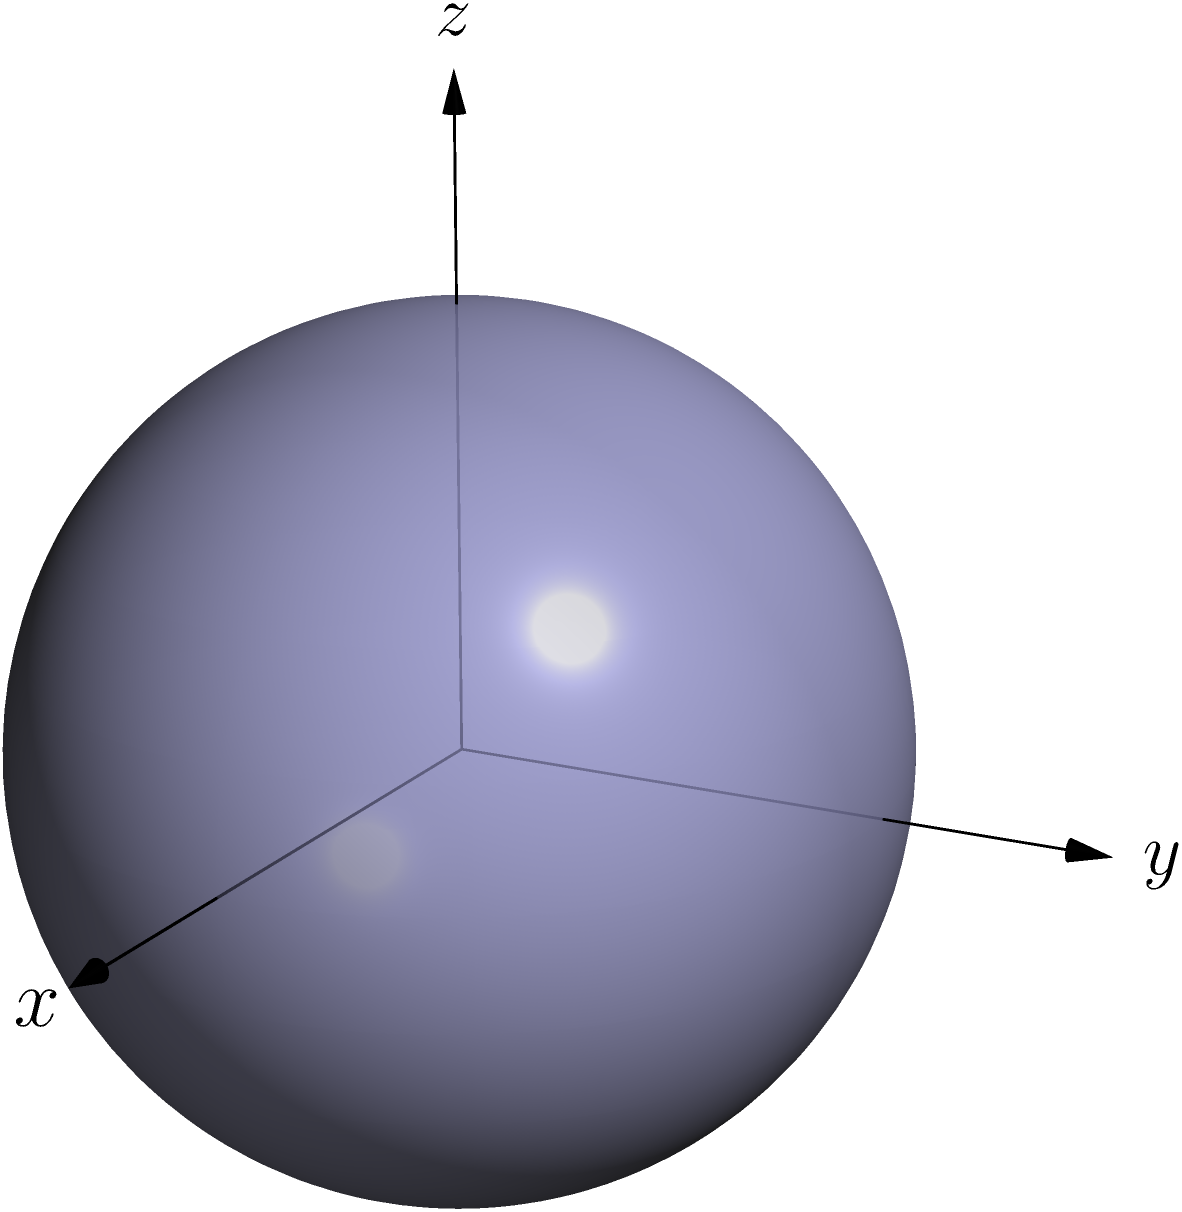As a tennis player, you're familiar with the concept of spin. Now, imagine a spherical satellite orbiting Earth. What is the order of the symmetry group of this satellite, assuming it has perfect spherical symmetry? Let's approach this step-by-step:

1) First, recall that the symmetry group of a sphere includes all rotations about any axis passing through its center, as well as all reflections across any plane passing through its center.

2) In group theory, we're interested in the number of distinct symmetry operations. For a sphere, we have:

   a) Rotations: Infinite number of rotation axes, each with an infinite number of rotation angles.
   b) Reflections: Infinite number of reflection planes.

3) The combination of all these symmetries forms the orthogonal group O(3), which is the group of all distance-preserving transformations of a three-dimensional Euclidean space that keep the origin fixed.

4) The order of a group is the number of elements in the group. For continuous groups like O(3), we use the concept of cardinality.

5) The orthogonal group O(3) is uncountably infinite, meaning its cardinality is that of the continuum.

6) In set theory, we denote the cardinality of the continuum as $\mathfrak{c}$ or $2^{\aleph_0}$, where $\aleph_0$ is the cardinality of the natural numbers.

Therefore, the order of the symmetry group of a perfect sphere is uncountably infinite, with cardinality $\mathfrak{c}$.
Answer: $\mathfrak{c}$ 